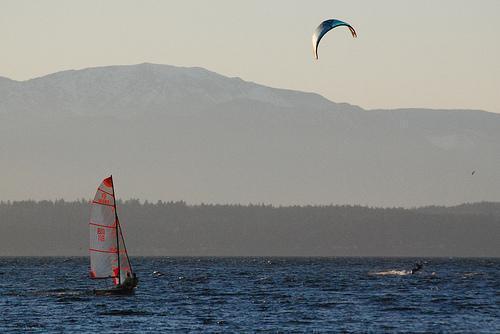How many boats are in the picture?
Give a very brief answer. 1. 